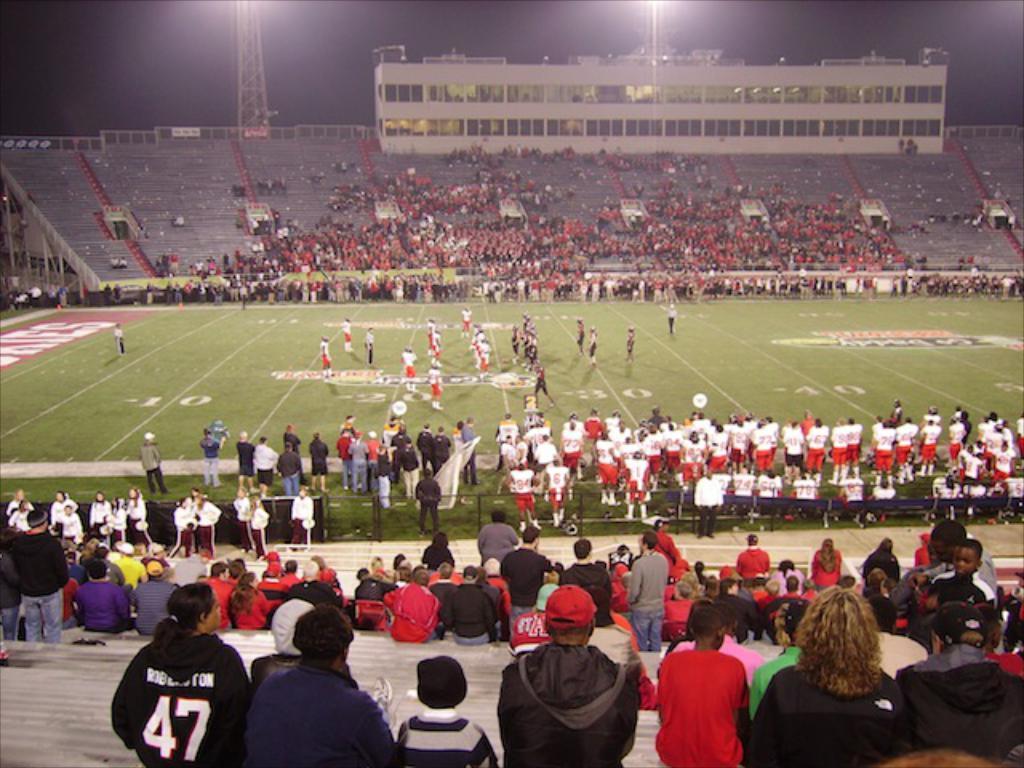Can you describe this image briefly? In this picture I see few people standing on the ground and few are seated on the left and right side of the stadium and I see a building and couple of lights to the poles. 